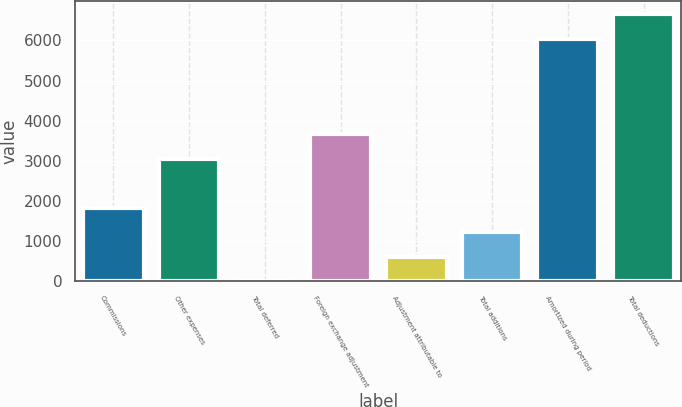Convert chart. <chart><loc_0><loc_0><loc_500><loc_500><bar_chart><fcel>Commissions<fcel>Other expenses<fcel>Total deferred<fcel>Foreign exchange adjustment<fcel>Adjustment attributable to<fcel>Total additions<fcel>Amortized during period<fcel>Total deductions<nl><fcel>1834.33<fcel>3056.81<fcel>0.61<fcel>3668.05<fcel>611.85<fcel>1223.09<fcel>6039<fcel>6650.24<nl></chart> 